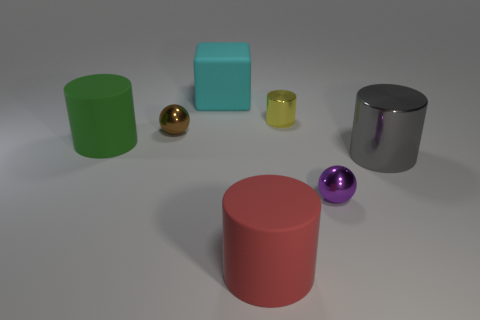What number of metallic objects are large objects or purple things?
Offer a terse response. 2. What material is the green thing?
Make the answer very short. Rubber. How many objects are in front of the large gray object?
Make the answer very short. 2. Does the tiny sphere that is to the left of the red cylinder have the same material as the big gray thing?
Your answer should be very brief. Yes. What number of large purple rubber objects have the same shape as the large red thing?
Keep it short and to the point. 0. What number of tiny objects are either yellow metal spheres or green objects?
Ensure brevity in your answer.  0. There is a shiny sphere that is on the right side of the small brown sphere; does it have the same color as the large cube?
Your answer should be compact. No. There is a large thing on the left side of the brown shiny object; is it the same color as the metallic cylinder that is behind the big metal cylinder?
Offer a terse response. No. Are there any tiny things made of the same material as the gray cylinder?
Make the answer very short. Yes. What number of red things are either large metallic cubes or cubes?
Offer a terse response. 0. 